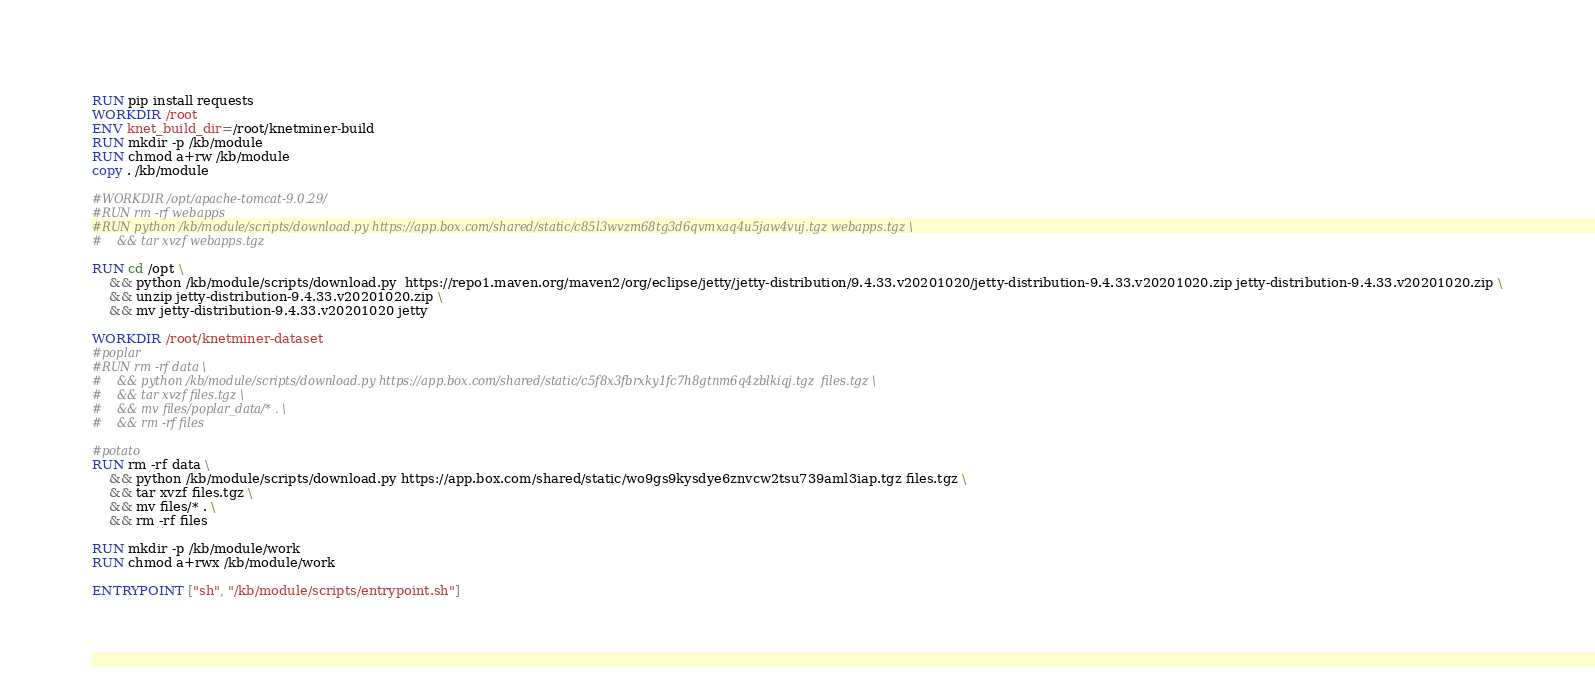<code> <loc_0><loc_0><loc_500><loc_500><_Dockerfile_>RUN pip install requests
WORKDIR /root
ENV knet_build_dir=/root/knetminer-build
RUN mkdir -p /kb/module
RUN chmod a+rw /kb/module
copy . /kb/module

#WORKDIR /opt/apache-tomcat-9.0.29/
#RUN rm -rf webapps
#RUN python /kb/module/scripts/download.py https://app.box.com/shared/static/c85l3wvzm68tg3d6qvmxaq4u5jaw4vuj.tgz webapps.tgz \
#    && tar xvzf webapps.tgz

RUN cd /opt \
    && python /kb/module/scripts/download.py  https://repo1.maven.org/maven2/org/eclipse/jetty/jetty-distribution/9.4.33.v20201020/jetty-distribution-9.4.33.v20201020.zip jetty-distribution-9.4.33.v20201020.zip \
    && unzip jetty-distribution-9.4.33.v20201020.zip \
    && mv jetty-distribution-9.4.33.v20201020 jetty 

WORKDIR /root/knetminer-dataset
#poplar
#RUN rm -rf data \
#    && python /kb/module/scripts/download.py https://app.box.com/shared/static/c5f8x3fbrxky1fc7h8gtnm6q4zblkiqj.tgz  files.tgz \
#    && tar xvzf files.tgz \
#    && mv files/poplar_data/* . \
#    && rm -rf files

#potato
RUN rm -rf data \
    && python /kb/module/scripts/download.py https://app.box.com/shared/static/wo9gs9kysdye6znvcw2tsu739aml3iap.tgz files.tgz \
    && tar xvzf files.tgz \
    && mv files/* . \
    && rm -rf files

RUN mkdir -p /kb/module/work
RUN chmod a+rwx /kb/module/work

ENTRYPOINT ["sh", "/kb/module/scripts/entrypoint.sh"]

</code> 